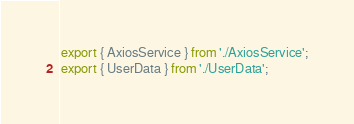<code> <loc_0><loc_0><loc_500><loc_500><_TypeScript_>export { AxiosService } from './AxiosService';
export { UserData } from './UserData';
</code> 